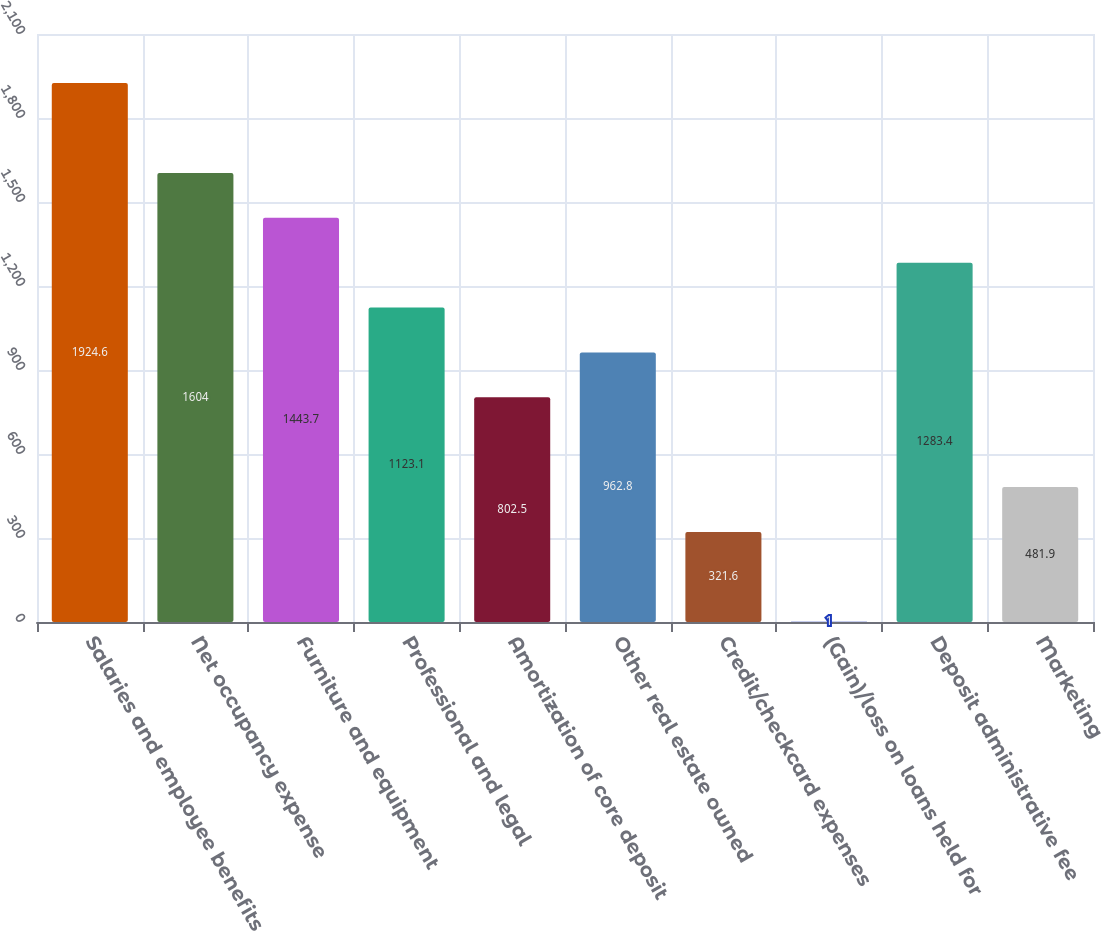Convert chart to OTSL. <chart><loc_0><loc_0><loc_500><loc_500><bar_chart><fcel>Salaries and employee benefits<fcel>Net occupancy expense<fcel>Furniture and equipment<fcel>Professional and legal<fcel>Amortization of core deposit<fcel>Other real estate owned<fcel>Credit/checkcard expenses<fcel>(Gain)/loss on loans held for<fcel>Deposit administrative fee<fcel>Marketing<nl><fcel>1924.6<fcel>1604<fcel>1443.7<fcel>1123.1<fcel>802.5<fcel>962.8<fcel>321.6<fcel>1<fcel>1283.4<fcel>481.9<nl></chart> 